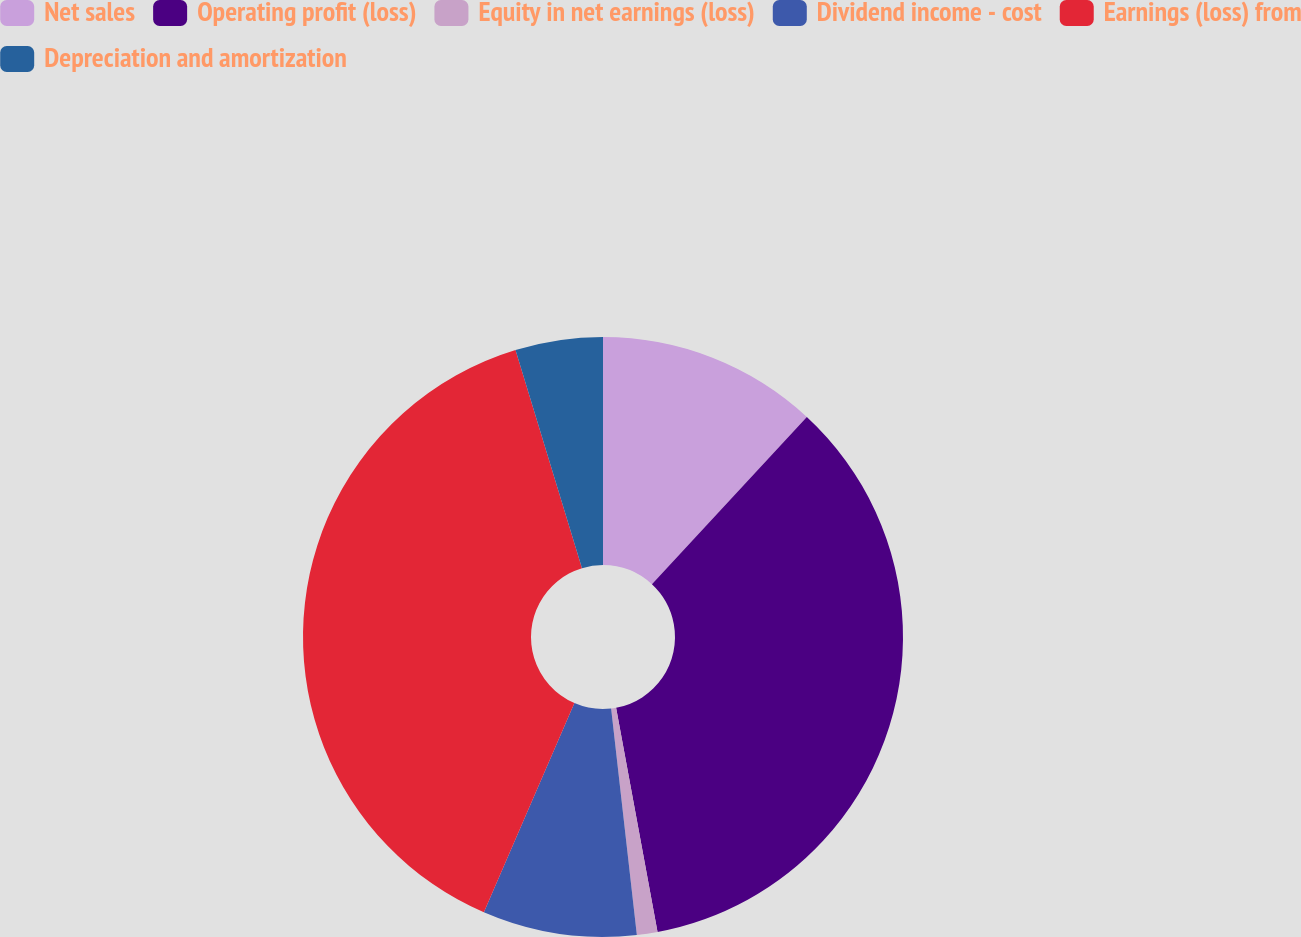Convert chart to OTSL. <chart><loc_0><loc_0><loc_500><loc_500><pie_chart><fcel>Net sales<fcel>Operating profit (loss)<fcel>Equity in net earnings (loss)<fcel>Dividend income - cost<fcel>Earnings (loss) from<fcel>Depreciation and amortization<nl><fcel>11.89%<fcel>35.2%<fcel>1.11%<fcel>8.3%<fcel>38.79%<fcel>4.71%<nl></chart> 